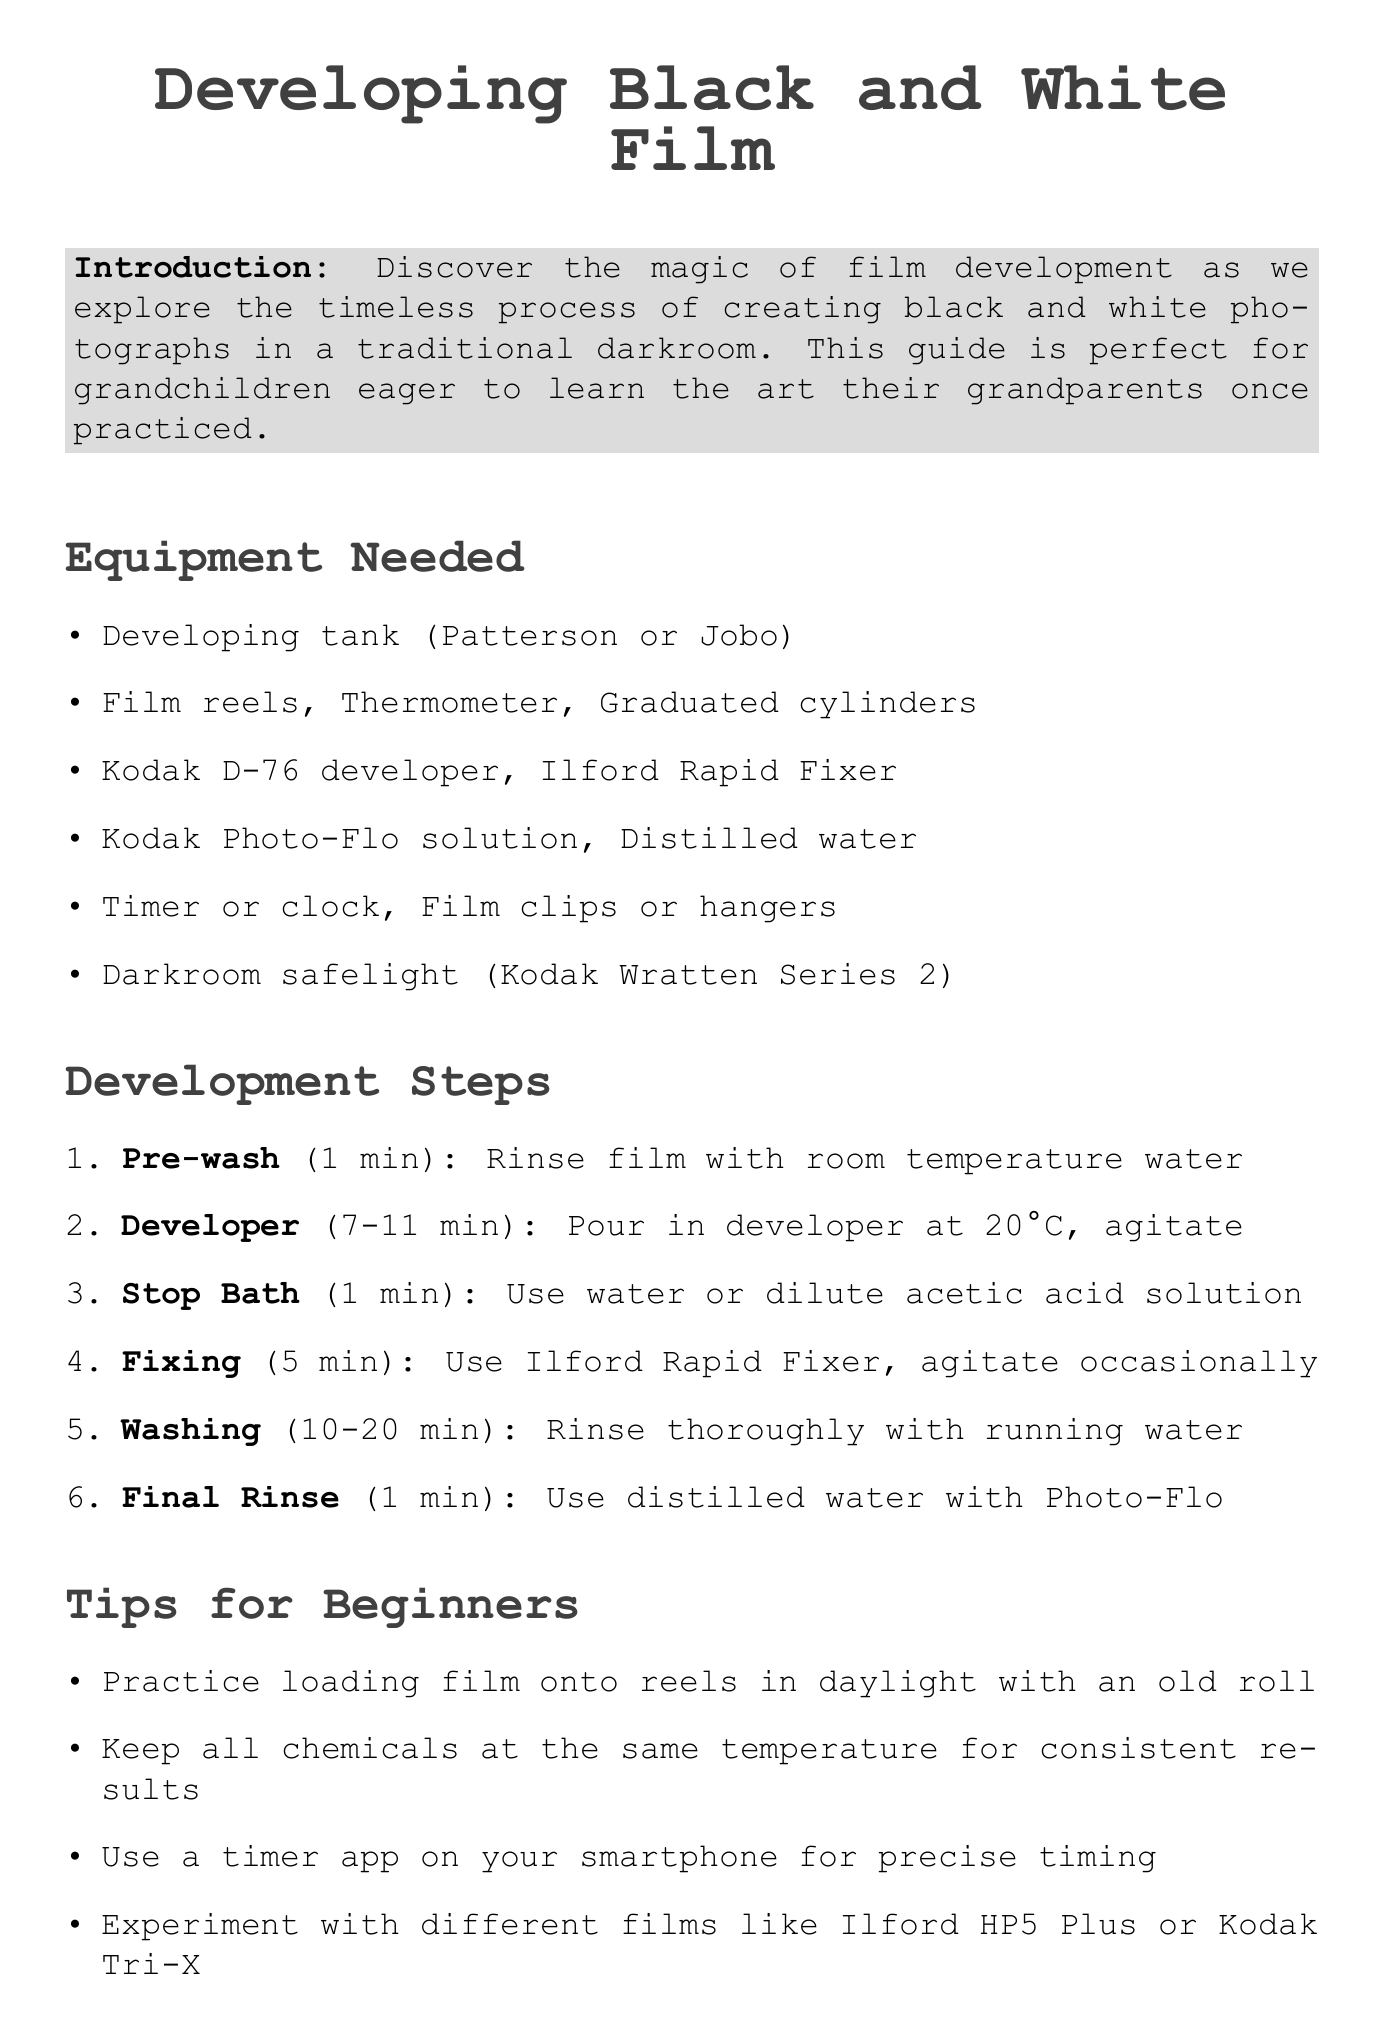What is the first step in the development process? The first step listed in the development steps is "Pre-wash".
Answer: Pre-wash How long should you develop the film? The duration for developing film varies based on film type, indicated as "7-11 minutes".
Answer: 7-11 minutes What is used for the final rinse? The final rinse involves using distilled water with Kodak Photo-Flo solution.
Answer: Kodak Photo-Flo solution What is one safety precaution mentioned? The document states multiple precautions, one of which is "Wear gloves to protect your hands from chemicals."
Answer: Wear gloves How long does washing take? The document specifies that washing takes "10-20 minutes".
Answer: 10-20 minutes 